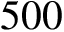Convert formula to latex. <formula><loc_0><loc_0><loc_500><loc_500>5 0 0</formula> 